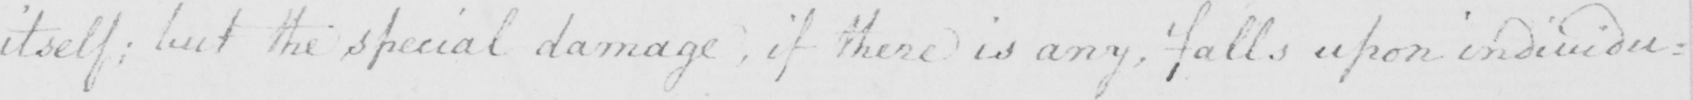Please provide the text content of this handwritten line. itself :  but the special damage , if there is any , falls upon individu= 